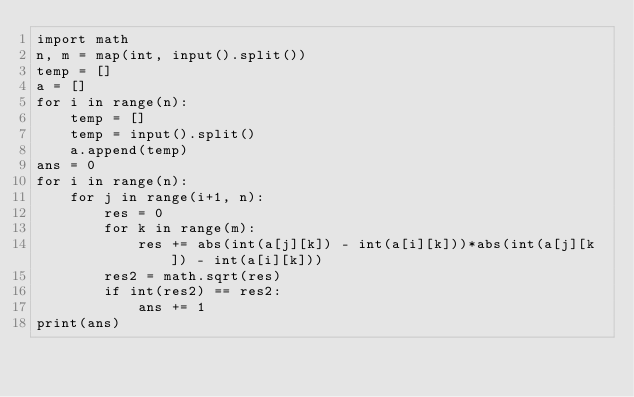Convert code to text. <code><loc_0><loc_0><loc_500><loc_500><_Python_>import math
n, m = map(int, input().split())
temp = []
a = []
for i in range(n):
    temp = []
    temp = input().split()
    a.append(temp)
ans = 0
for i in range(n):
    for j in range(i+1, n):
        res = 0
        for k in range(m):
            res += abs(int(a[j][k]) - int(a[i][k]))*abs(int(a[j][k]) - int(a[i][k]))
        res2 = math.sqrt(res)
        if int(res2) == res2:
            ans += 1
print(ans)
</code> 